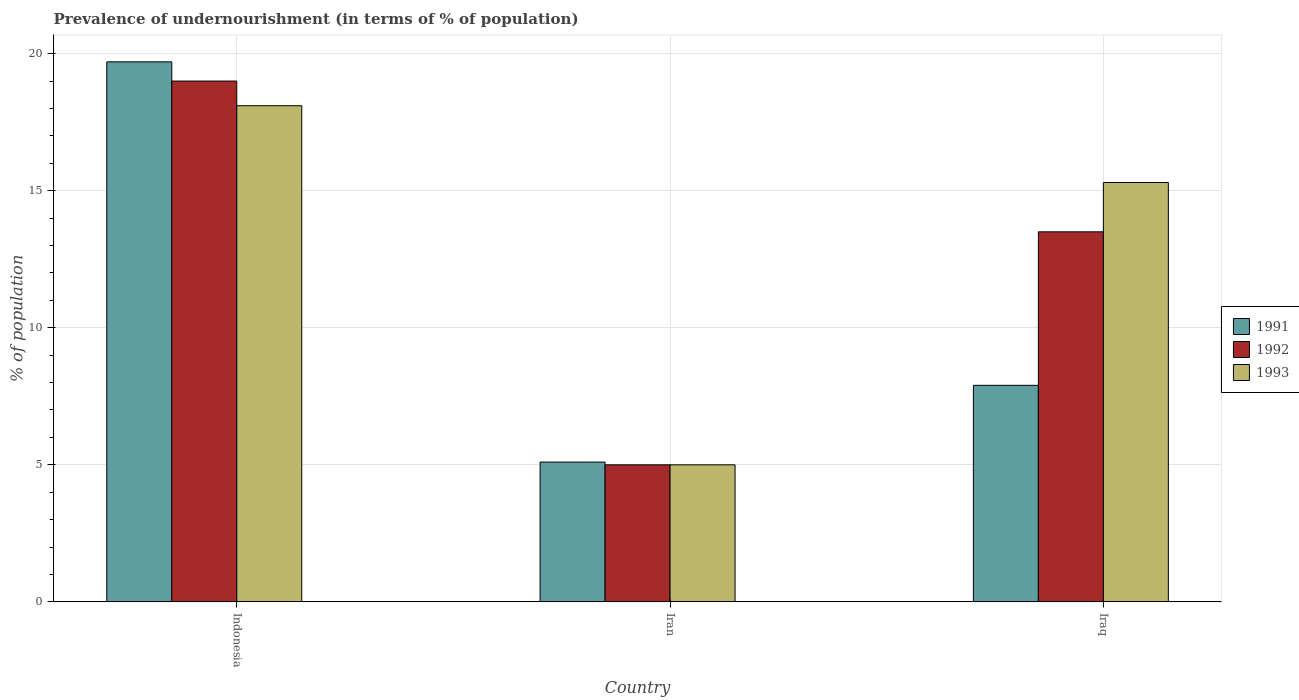How many different coloured bars are there?
Offer a terse response. 3. Are the number of bars on each tick of the X-axis equal?
Make the answer very short. Yes. How many bars are there on the 2nd tick from the left?
Make the answer very short. 3. How many bars are there on the 3rd tick from the right?
Make the answer very short. 3. What is the label of the 2nd group of bars from the left?
Your answer should be compact. Iran. What is the percentage of undernourished population in 1993 in Iraq?
Provide a short and direct response. 15.3. Across all countries, what is the maximum percentage of undernourished population in 1993?
Give a very brief answer. 18.1. In which country was the percentage of undernourished population in 1991 minimum?
Ensure brevity in your answer.  Iran. What is the total percentage of undernourished population in 1992 in the graph?
Keep it short and to the point. 37.5. What is the average percentage of undernourished population in 1993 per country?
Your response must be concise. 12.8. What is the difference between the percentage of undernourished population of/in 1992 and percentage of undernourished population of/in 1993 in Indonesia?
Provide a short and direct response. 0.9. What is the ratio of the percentage of undernourished population in 1993 in Indonesia to that in Iran?
Provide a short and direct response. 3.62. Is the percentage of undernourished population in 1992 in Indonesia less than that in Iran?
Make the answer very short. No. Is the difference between the percentage of undernourished population in 1992 in Iran and Iraq greater than the difference between the percentage of undernourished population in 1993 in Iran and Iraq?
Provide a succinct answer. Yes. What is the difference between the highest and the second highest percentage of undernourished population in 1992?
Give a very brief answer. -14. In how many countries, is the percentage of undernourished population in 1993 greater than the average percentage of undernourished population in 1993 taken over all countries?
Your response must be concise. 2. What does the 2nd bar from the right in Iran represents?
Give a very brief answer. 1992. Is it the case that in every country, the sum of the percentage of undernourished population in 1993 and percentage of undernourished population in 1991 is greater than the percentage of undernourished population in 1992?
Offer a terse response. Yes. How many bars are there?
Keep it short and to the point. 9. Are all the bars in the graph horizontal?
Ensure brevity in your answer.  No. How many countries are there in the graph?
Offer a very short reply. 3. What is the difference between two consecutive major ticks on the Y-axis?
Your answer should be very brief. 5. Are the values on the major ticks of Y-axis written in scientific E-notation?
Your answer should be very brief. No. Does the graph contain grids?
Your answer should be very brief. Yes. Where does the legend appear in the graph?
Your answer should be compact. Center right. How many legend labels are there?
Keep it short and to the point. 3. What is the title of the graph?
Ensure brevity in your answer.  Prevalence of undernourishment (in terms of % of population). Does "1995" appear as one of the legend labels in the graph?
Your answer should be compact. No. What is the label or title of the Y-axis?
Make the answer very short. % of population. What is the % of population in 1991 in Indonesia?
Offer a terse response. 19.7. What is the % of population in 1993 in Indonesia?
Your answer should be compact. 18.1. What is the % of population in 1993 in Iran?
Make the answer very short. 5. What is the % of population in 1993 in Iraq?
Provide a succinct answer. 15.3. Across all countries, what is the maximum % of population of 1993?
Give a very brief answer. 18.1. Across all countries, what is the minimum % of population in 1993?
Provide a short and direct response. 5. What is the total % of population of 1991 in the graph?
Your response must be concise. 32.7. What is the total % of population of 1992 in the graph?
Provide a short and direct response. 37.5. What is the total % of population in 1993 in the graph?
Give a very brief answer. 38.4. What is the difference between the % of population in 1991 in Indonesia and that in Iraq?
Offer a terse response. 11.8. What is the difference between the % of population in 1993 in Indonesia and that in Iraq?
Offer a terse response. 2.8. What is the difference between the % of population in 1991 in Iran and that in Iraq?
Your response must be concise. -2.8. What is the difference between the % of population of 1992 in Iran and that in Iraq?
Give a very brief answer. -8.5. What is the difference between the % of population in 1993 in Iran and that in Iraq?
Offer a terse response. -10.3. What is the difference between the % of population in 1991 in Indonesia and the % of population in 1992 in Iran?
Provide a succinct answer. 14.7. What is the difference between the % of population of 1992 in Indonesia and the % of population of 1993 in Iran?
Keep it short and to the point. 14. What is the difference between the % of population of 1992 in Iran and the % of population of 1993 in Iraq?
Keep it short and to the point. -10.3. What is the average % of population of 1991 per country?
Your answer should be very brief. 10.9. What is the average % of population in 1993 per country?
Offer a terse response. 12.8. What is the difference between the % of population in 1991 and % of population in 1992 in Indonesia?
Your answer should be very brief. 0.7. What is the difference between the % of population of 1991 and % of population of 1993 in Iran?
Offer a very short reply. 0.1. What is the difference between the % of population of 1991 and % of population of 1992 in Iraq?
Provide a succinct answer. -5.6. What is the difference between the % of population of 1992 and % of population of 1993 in Iraq?
Keep it short and to the point. -1.8. What is the ratio of the % of population in 1991 in Indonesia to that in Iran?
Provide a short and direct response. 3.86. What is the ratio of the % of population of 1992 in Indonesia to that in Iran?
Ensure brevity in your answer.  3.8. What is the ratio of the % of population of 1993 in Indonesia to that in Iran?
Give a very brief answer. 3.62. What is the ratio of the % of population of 1991 in Indonesia to that in Iraq?
Offer a terse response. 2.49. What is the ratio of the % of population of 1992 in Indonesia to that in Iraq?
Your answer should be compact. 1.41. What is the ratio of the % of population in 1993 in Indonesia to that in Iraq?
Offer a very short reply. 1.18. What is the ratio of the % of population in 1991 in Iran to that in Iraq?
Give a very brief answer. 0.65. What is the ratio of the % of population of 1992 in Iran to that in Iraq?
Offer a very short reply. 0.37. What is the ratio of the % of population in 1993 in Iran to that in Iraq?
Offer a very short reply. 0.33. What is the difference between the highest and the second highest % of population in 1991?
Provide a short and direct response. 11.8. What is the difference between the highest and the second highest % of population of 1992?
Make the answer very short. 5.5. 